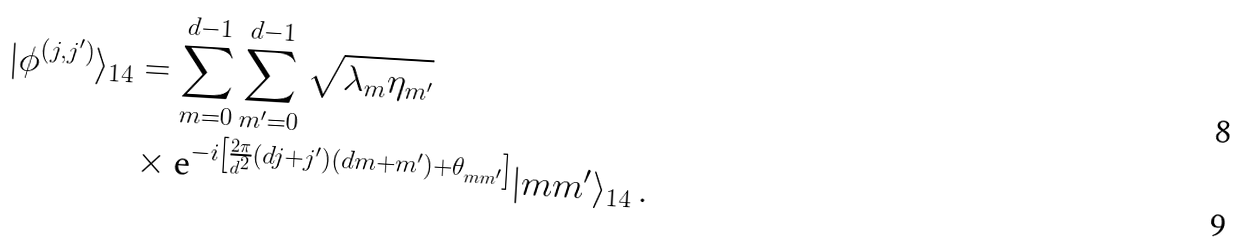Convert formula to latex. <formula><loc_0><loc_0><loc_500><loc_500>| \phi ^ { ( j , j ^ { \prime } ) } \rangle _ { 1 4 } & = \sum _ { m = 0 } ^ { d - 1 } \sum _ { m ^ { \prime } = 0 } ^ { d - 1 } \sqrt { \lambda _ { m } \eta _ { m ^ { \prime } } } \\ & \times \text {e} ^ { - i \left [ \frac { 2 \pi } { d ^ { 2 } } ( d j + j ^ { \prime } ) ( d m + m ^ { \prime } ) + \theta _ { m m ^ { \prime } } \right ] } | m m ^ { \prime } \rangle _ { 1 4 } \, .</formula> 